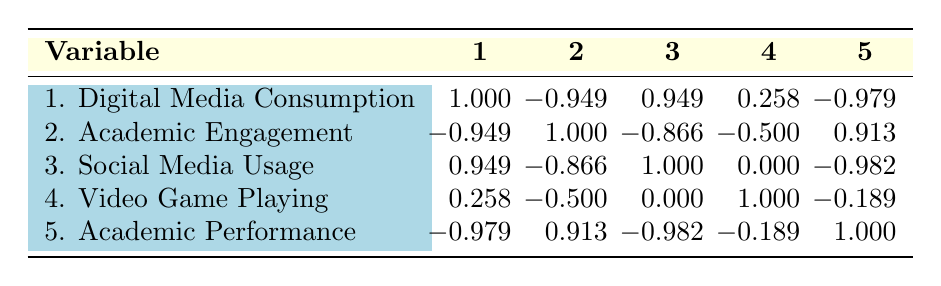What is the correlation between digital media consumption and academic performance? The table shows that the correlation coefficient between digital media consumption (1) and academic performance (5) is -0.979. This indicates a very strong negative correlation, suggesting that higher digital media consumption is associated with lower academic performance.
Answer: -0.979 Is there a positive correlation between academic engagement and social media usage? The correlation coefficient between academic engagement (2) and social media usage (3) is -0.866, which means there is a negative correlation. Therefore, there is no positive correlation between these two variables.
Answer: No What is the correlation coefficient between video game playing and academic engagement? The correlation coefficient between video game playing (4) and academic engagement (2) is -0.500. This indicates a moderate negative correlation, suggesting that more time spent playing video games is associated with lower academic engagement.
Answer: -0.500 If we consider the average correlation for digital media consumption, academic engagement, and academic performance, what would it be? The coefficients for digital media consumption (1) to academic engagement (2) is -0.949, and to academic performance (5) is -0.979. Averaging these gives (-0.949 + -0.979) / 2 = -0.964. Therefore, the average correlation is -0.964.
Answer: -0.964 Is there a correlation between social media usage and video game playing? The correlation coefficient between social media usage (3) and video game playing (4) is 0.000, which indicates no correlation between these two variables.
Answer: Yes 